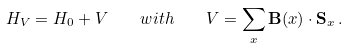Convert formula to latex. <formula><loc_0><loc_0><loc_500><loc_500>H _ { V } = H _ { 0 } + V \quad w i t h \quad V = \sum _ { x } { \mathbf B } ( x ) \cdot { \mathbf S } _ { x } \, .</formula> 